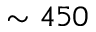<formula> <loc_0><loc_0><loc_500><loc_500>\sim 4 5 0</formula> 